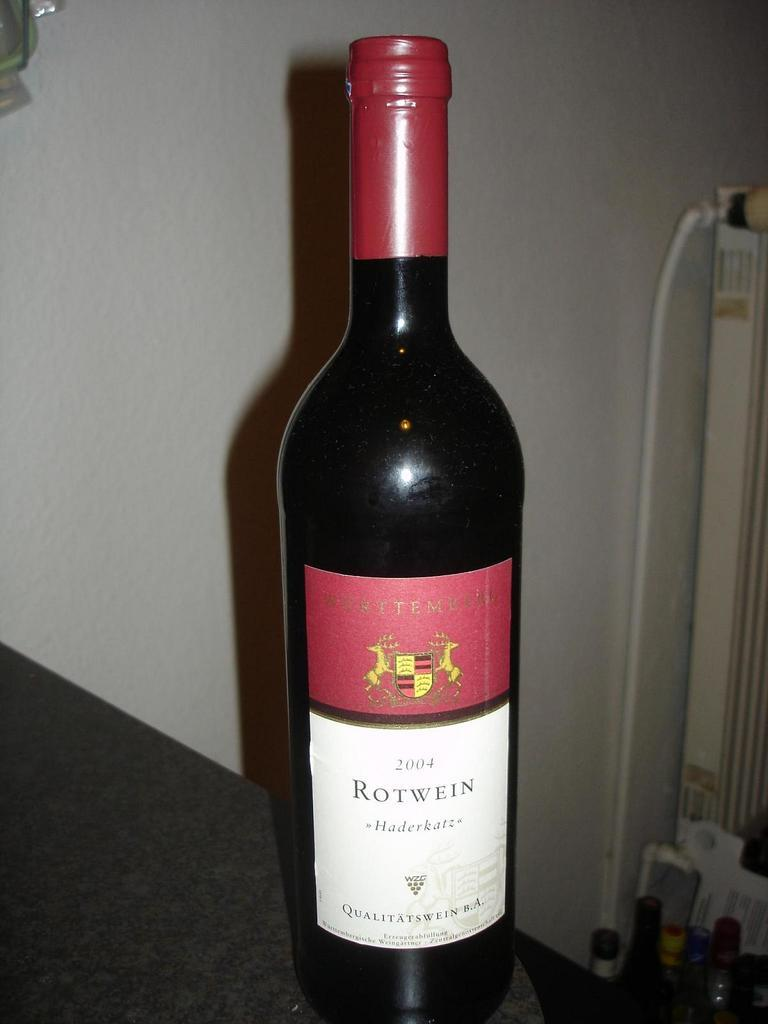<image>
Provide a brief description of the given image. the word Rotwein that is on a wine bottle 